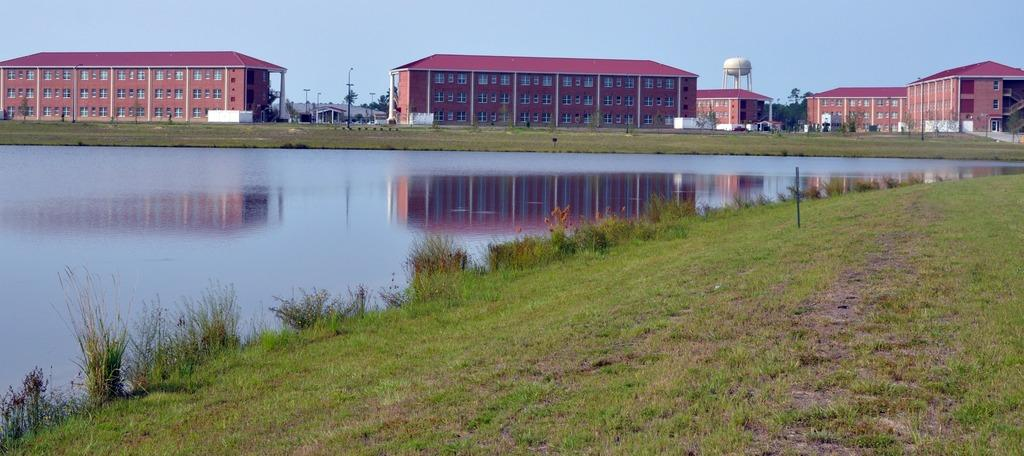What can be seen on the left side of the image? There are plants and water on the left side of the image. What is visible in the background of the image? There are buildings, poles, and trees in the background of the image. What verse is being recited by the spoon in the image? There is no spoon present in the image, and therefore no verse can be recited. What is the head doing in the image? There is no head present in the image, so it is not possible to determine what it might be doing. 